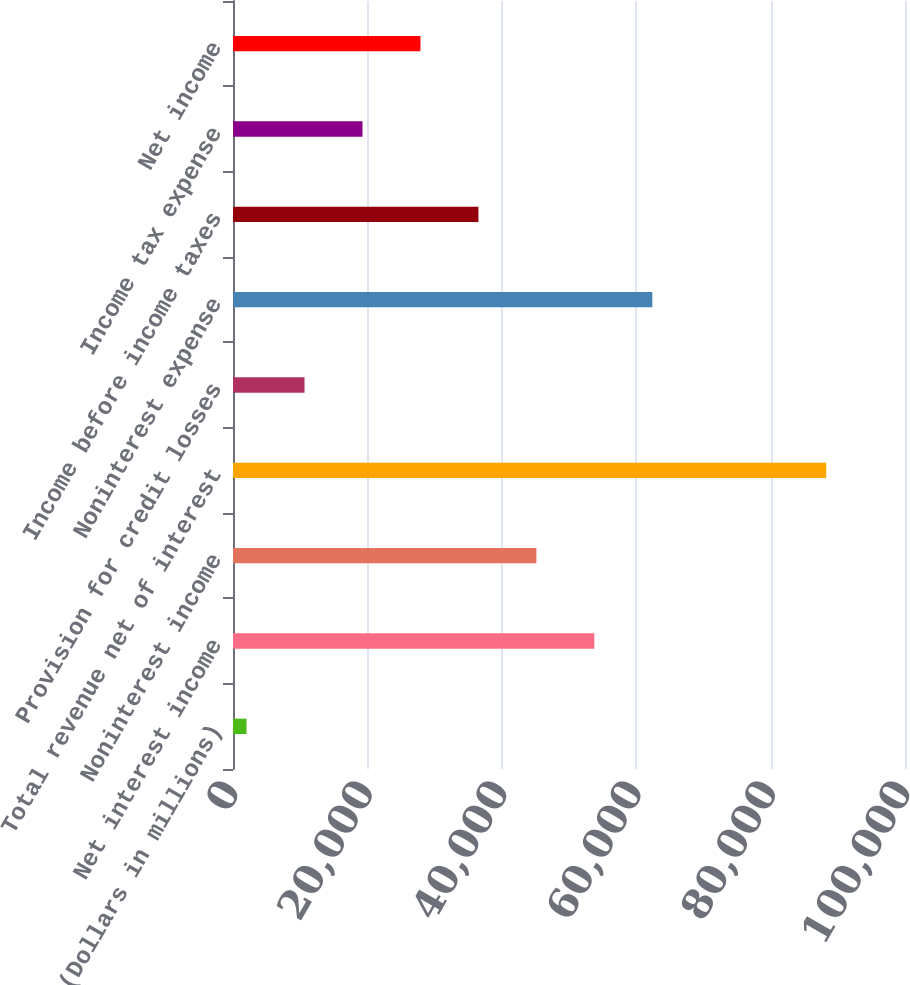Convert chart to OTSL. <chart><loc_0><loc_0><loc_500><loc_500><bar_chart><fcel>(Dollars in millions)<fcel>Net interest income<fcel>Noninterest income<fcel>Total revenue net of interest<fcel>Provision for credit losses<fcel>Noninterest expense<fcel>Income before income taxes<fcel>Income tax expense<fcel>Net income<nl><fcel>2017<fcel>53773<fcel>45147<fcel>88277<fcel>10643<fcel>62399<fcel>36521<fcel>19269<fcel>27895<nl></chart> 